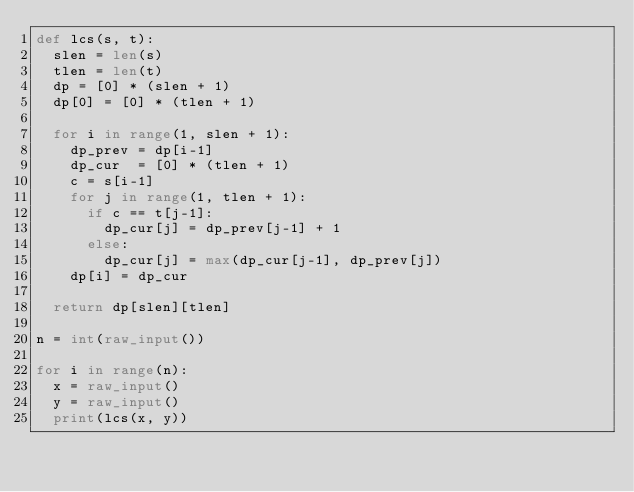Convert code to text. <code><loc_0><loc_0><loc_500><loc_500><_Python_>def lcs(s, t):
  slen = len(s)
  tlen = len(t)
  dp = [0] * (slen + 1)
  dp[0] = [0] * (tlen + 1)

  for i in range(1, slen + 1):
    dp_prev = dp[i-1]
    dp_cur  = [0] * (tlen + 1)
    c = s[i-1]
    for j in range(1, tlen + 1):
      if c == t[j-1]:
        dp_cur[j] = dp_prev[j-1] + 1
      else:
        dp_cur[j] = max(dp_cur[j-1], dp_prev[j])
    dp[i] = dp_cur

  return dp[slen][tlen]

n = int(raw_input())

for i in range(n):
  x = raw_input()
  y = raw_input()
  print(lcs(x, y))</code> 